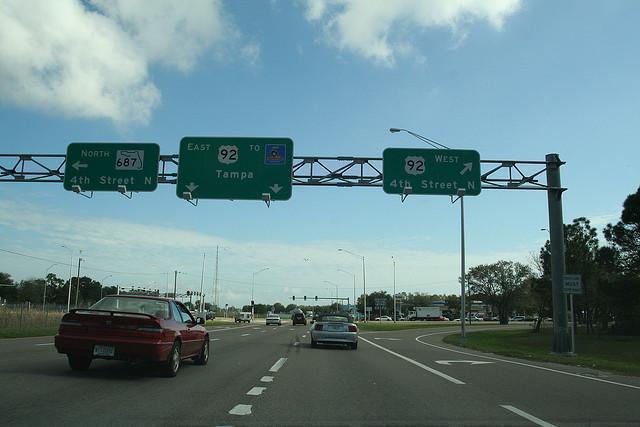What is the right lane used for?
Choose the correct response, then elucidate: 'Answer: answer
Rationale: rationale.'
Options: Turns, parking, racing, paying. Answer: turns.
Rationale: The right lane has arrows painted on it showing that all those in that lane need to exit towards the right. 